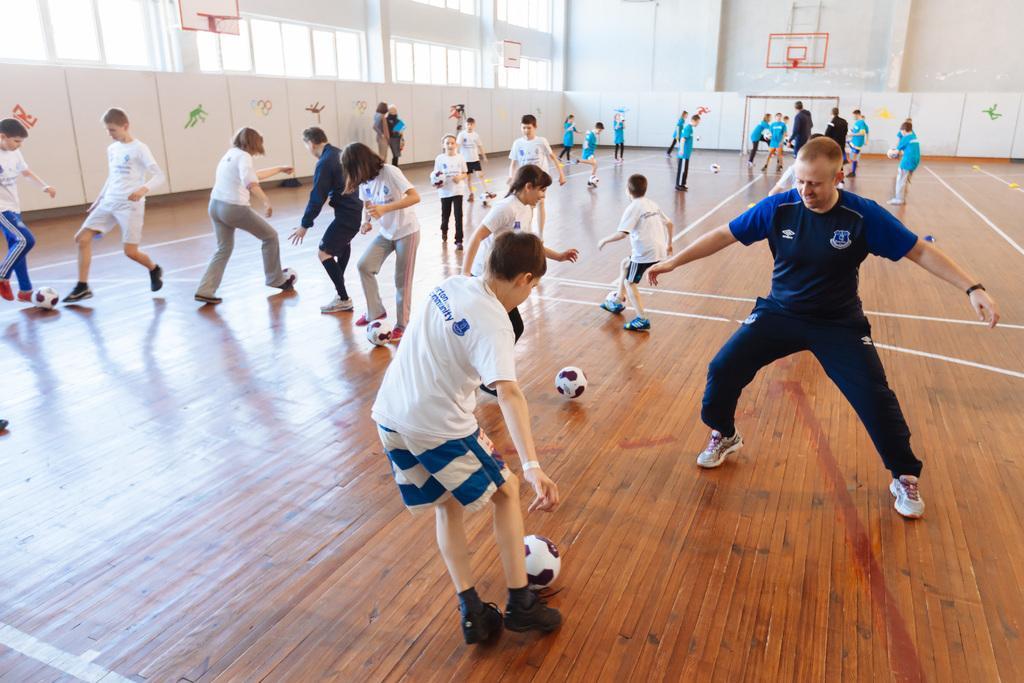Please provide a concise description of this image. In this image there are walls, windows, people, wooden floor, balls, three basketball hoops and objects. Few people are playing with balls.   